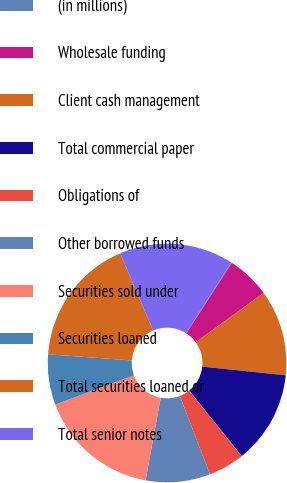<chart> <loc_0><loc_0><loc_500><loc_500><pie_chart><fcel>(in millions)<fcel>Wholesale funding<fcel>Client cash management<fcel>Total commercial paper<fcel>Obligations of<fcel>Other borrowed funds<fcel>Securities sold under<fcel>Securities loaned<fcel>Total securities loaned or<fcel>Total senior notes<nl><fcel>0.1%<fcel>5.87%<fcel>11.63%<fcel>12.6%<fcel>4.9%<fcel>8.75%<fcel>16.44%<fcel>6.83%<fcel>17.4%<fcel>15.48%<nl></chart> 